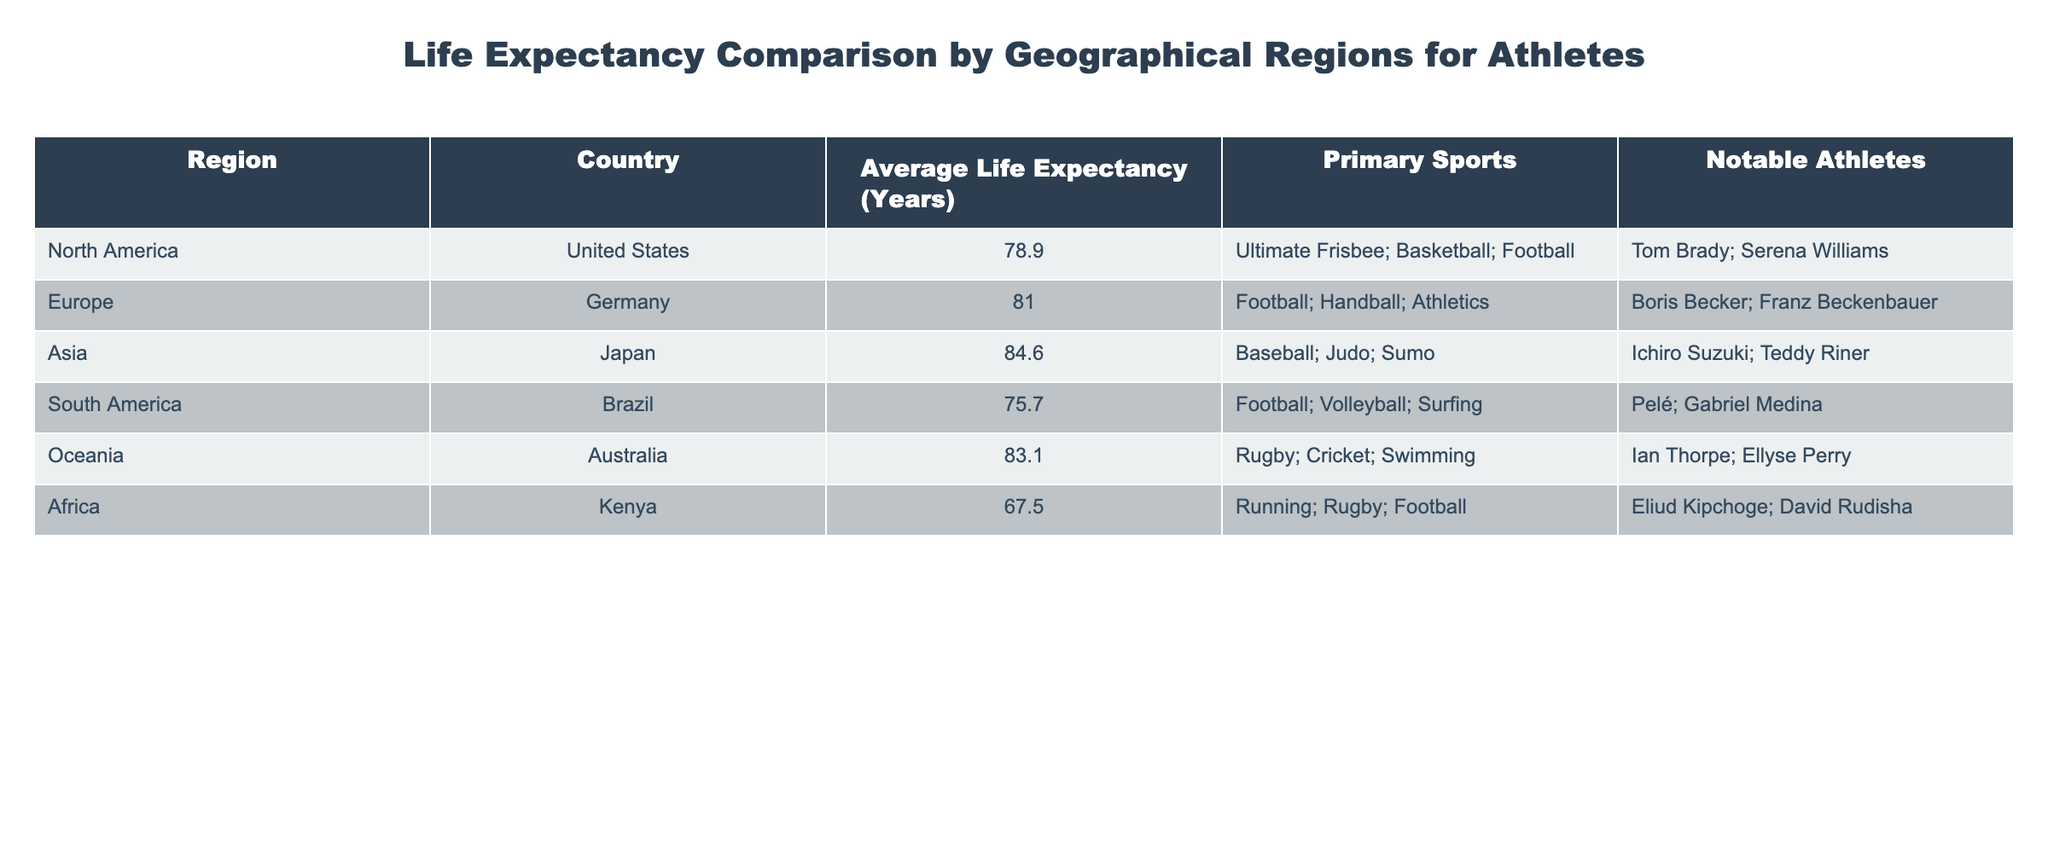What is the average life expectancy for athletes in North America? The table shows that the average life expectancy for athletes in the United States, which is the only entry for North America, is 78.9 years. Therefore, the average for North America is also 78.9 years.
Answer: 78.9 Which region has the highest average life expectancy for athletes? By comparing the average life expectancies from each region listed, Japan has the highest average life expectancy at 84.6 years.
Answer: Japan What is the life expectancy difference between athletes in Asia and Africa? The average life expectancy for athletes in Asia, specifically Japan, is 84.6 years, while in Kenya (Africa) it is 67.5 years. The difference is 84.6 - 67.5 = 17.1 years.
Answer: 17.1 Does any South American country have a higher average life expectancy than any African country? Looking at Brazil's average life expectancy of 75.7 years and Kenya's of 67.5 years, Brazil does have a higher average life expectancy compared to Kenya.
Answer: Yes What sports are associated with athletes from Europe? The table lists three primary sports for Germany in Europe: Football, Handball, and Athletics.
Answer: Football, Handball, Athletics What is the average life expectancy for athletes across all regions represented in the table? To find the average, sum the life expectancies: 78.9 (US) + 81.0 (Germany) + 84.6 (Japan) + 75.7 (Brazil) + 83.1 (Australia) + 67.5 (Kenya) = 471.8. Then divide by 6 regions, 471.8 / 6 = 78.63.
Answer: 78.63 Which country has the lowest life expectancy among the regions listed? Upon reviewing the data, Kenya has the lowest life expectancy for athletes with an average of 67.5 years.
Answer: Kenya Are there any notable athletes listed for the African region? The notable athletes mentioned for Kenya in the African region are Eliud Kipchoge and David Rudisha. Therefore, the answer is yes.
Answer: Yes What are the primary sports associated with athletes in Oceania? The table indicates that the primary sports in Australia are Rugby, Cricket, and Swimming.
Answer: Rugby, Cricket, Swimming Is there a region where the average life expectancy is above 80 years? From the table, both Europe (81.0 years) and Asia (84.6 years) have average life expectancies above 80 years.
Answer: Yes 